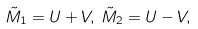<formula> <loc_0><loc_0><loc_500><loc_500>\tilde { M } _ { 1 } = U + V , \, \tilde { M } _ { 2 } = U - V ,</formula> 